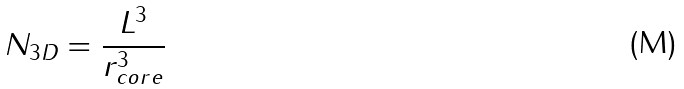Convert formula to latex. <formula><loc_0><loc_0><loc_500><loc_500>N _ { 3 D } = \frac { L ^ { 3 } } { r _ { c o r e } ^ { 3 } }</formula> 